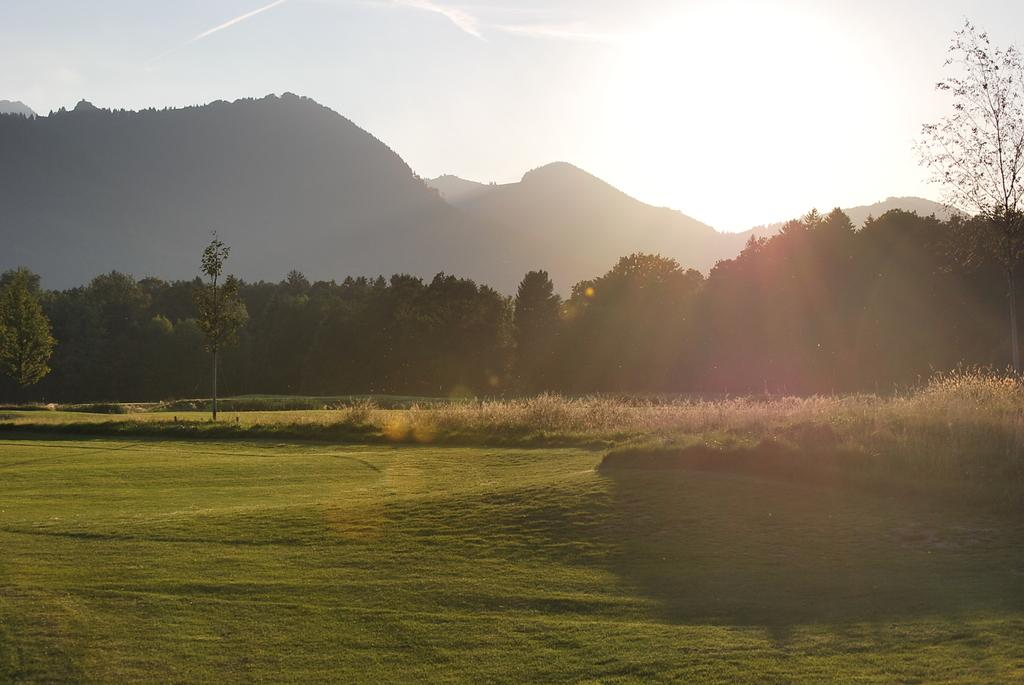What type of vegetation is present on the ground in the image? There is grass on the ground in the image. What can be seen in the background of the image? There are trees and hills visible in the background of the image. What is visible in the sky in the image? The sky is visible in the background of the image. What type of hook is hanging from the tree in the image? There is no hook present in the image; it features grass, trees, hills, and the sky. 